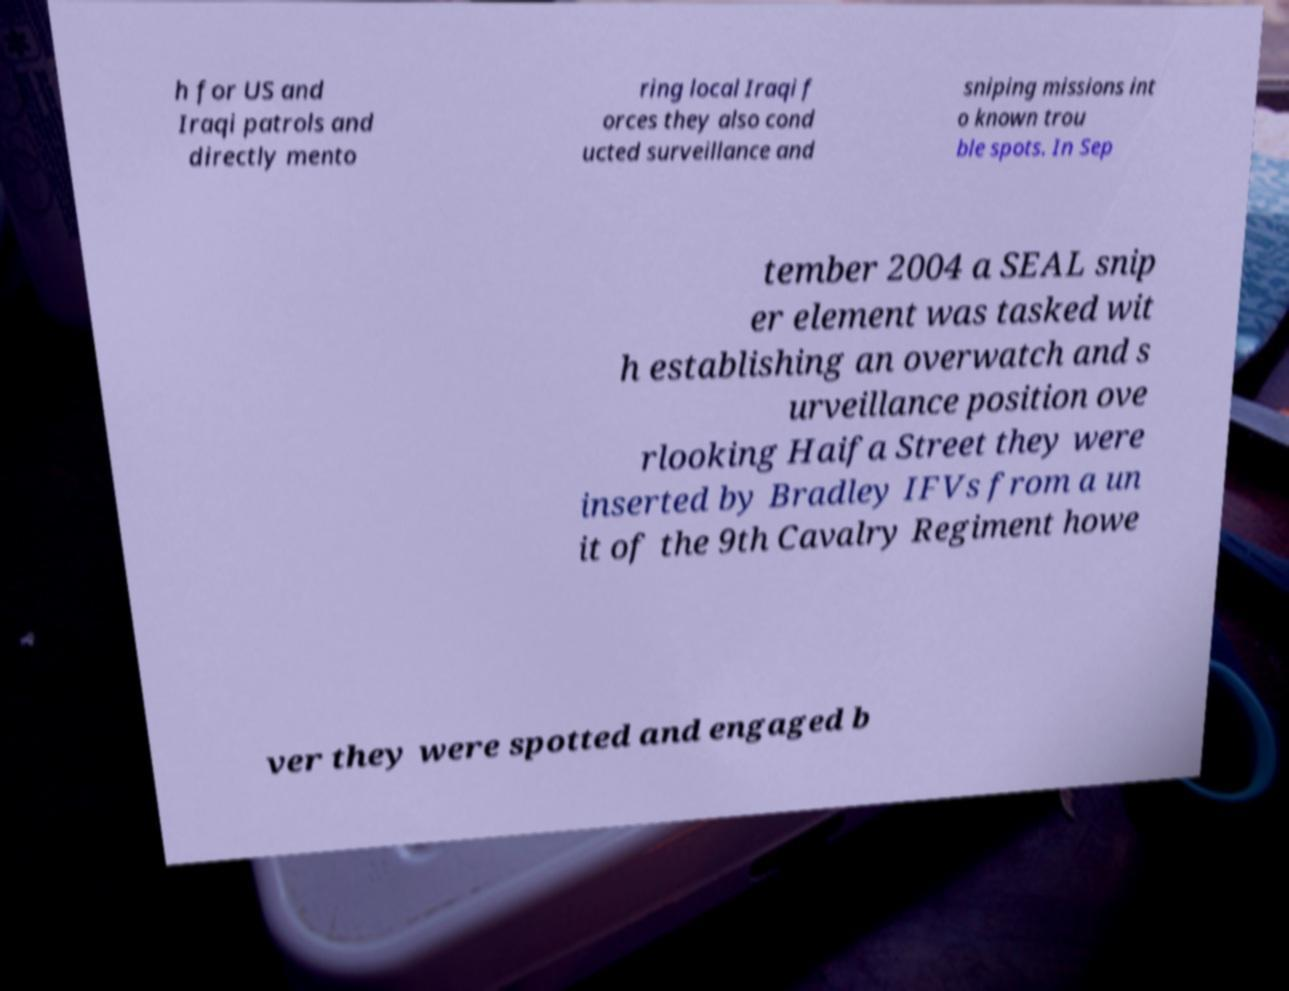For documentation purposes, I need the text within this image transcribed. Could you provide that? h for US and Iraqi patrols and directly mento ring local Iraqi f orces they also cond ucted surveillance and sniping missions int o known trou ble spots. In Sep tember 2004 a SEAL snip er element was tasked wit h establishing an overwatch and s urveillance position ove rlooking Haifa Street they were inserted by Bradley IFVs from a un it of the 9th Cavalry Regiment howe ver they were spotted and engaged b 